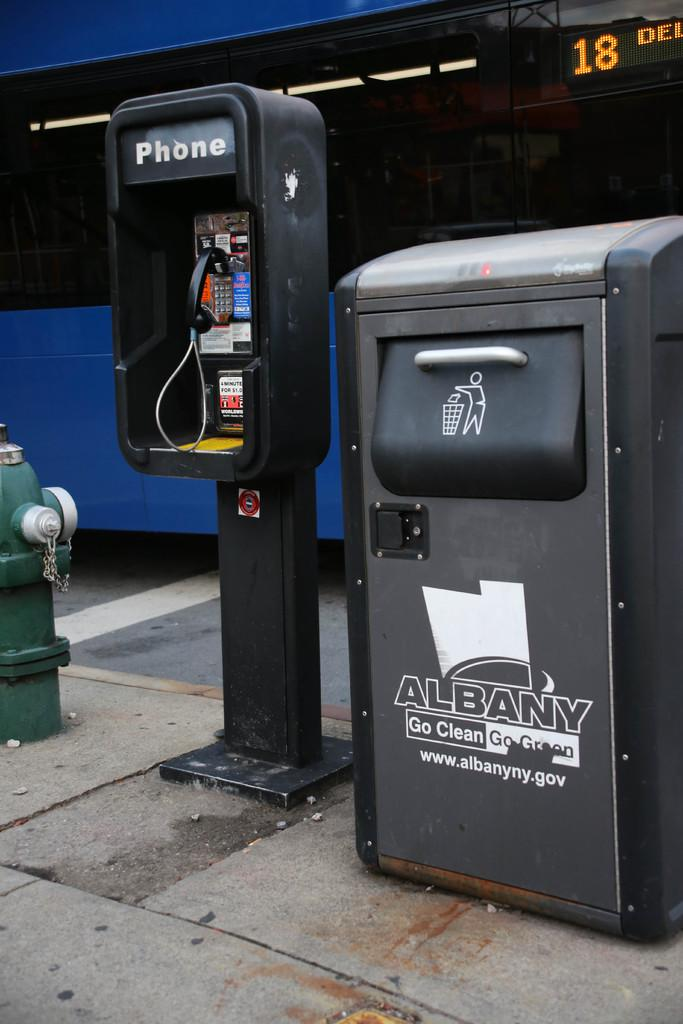<image>
Share a concise interpretation of the image provided. A trash can says "ALBANY Go Clean Go Green" on the front. 